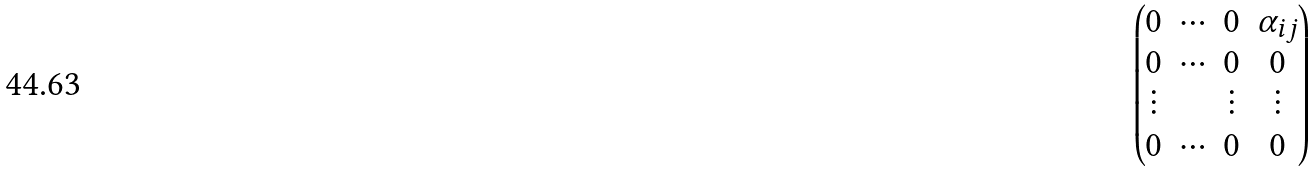Convert formula to latex. <formula><loc_0><loc_0><loc_500><loc_500>\begin{pmatrix} 0 & \cdots & 0 & \alpha _ { i j } \\ 0 & \cdots & 0 & 0 \\ \vdots & & \vdots & \vdots \\ 0 & \cdots & 0 & 0 \\ \end{pmatrix}</formula> 